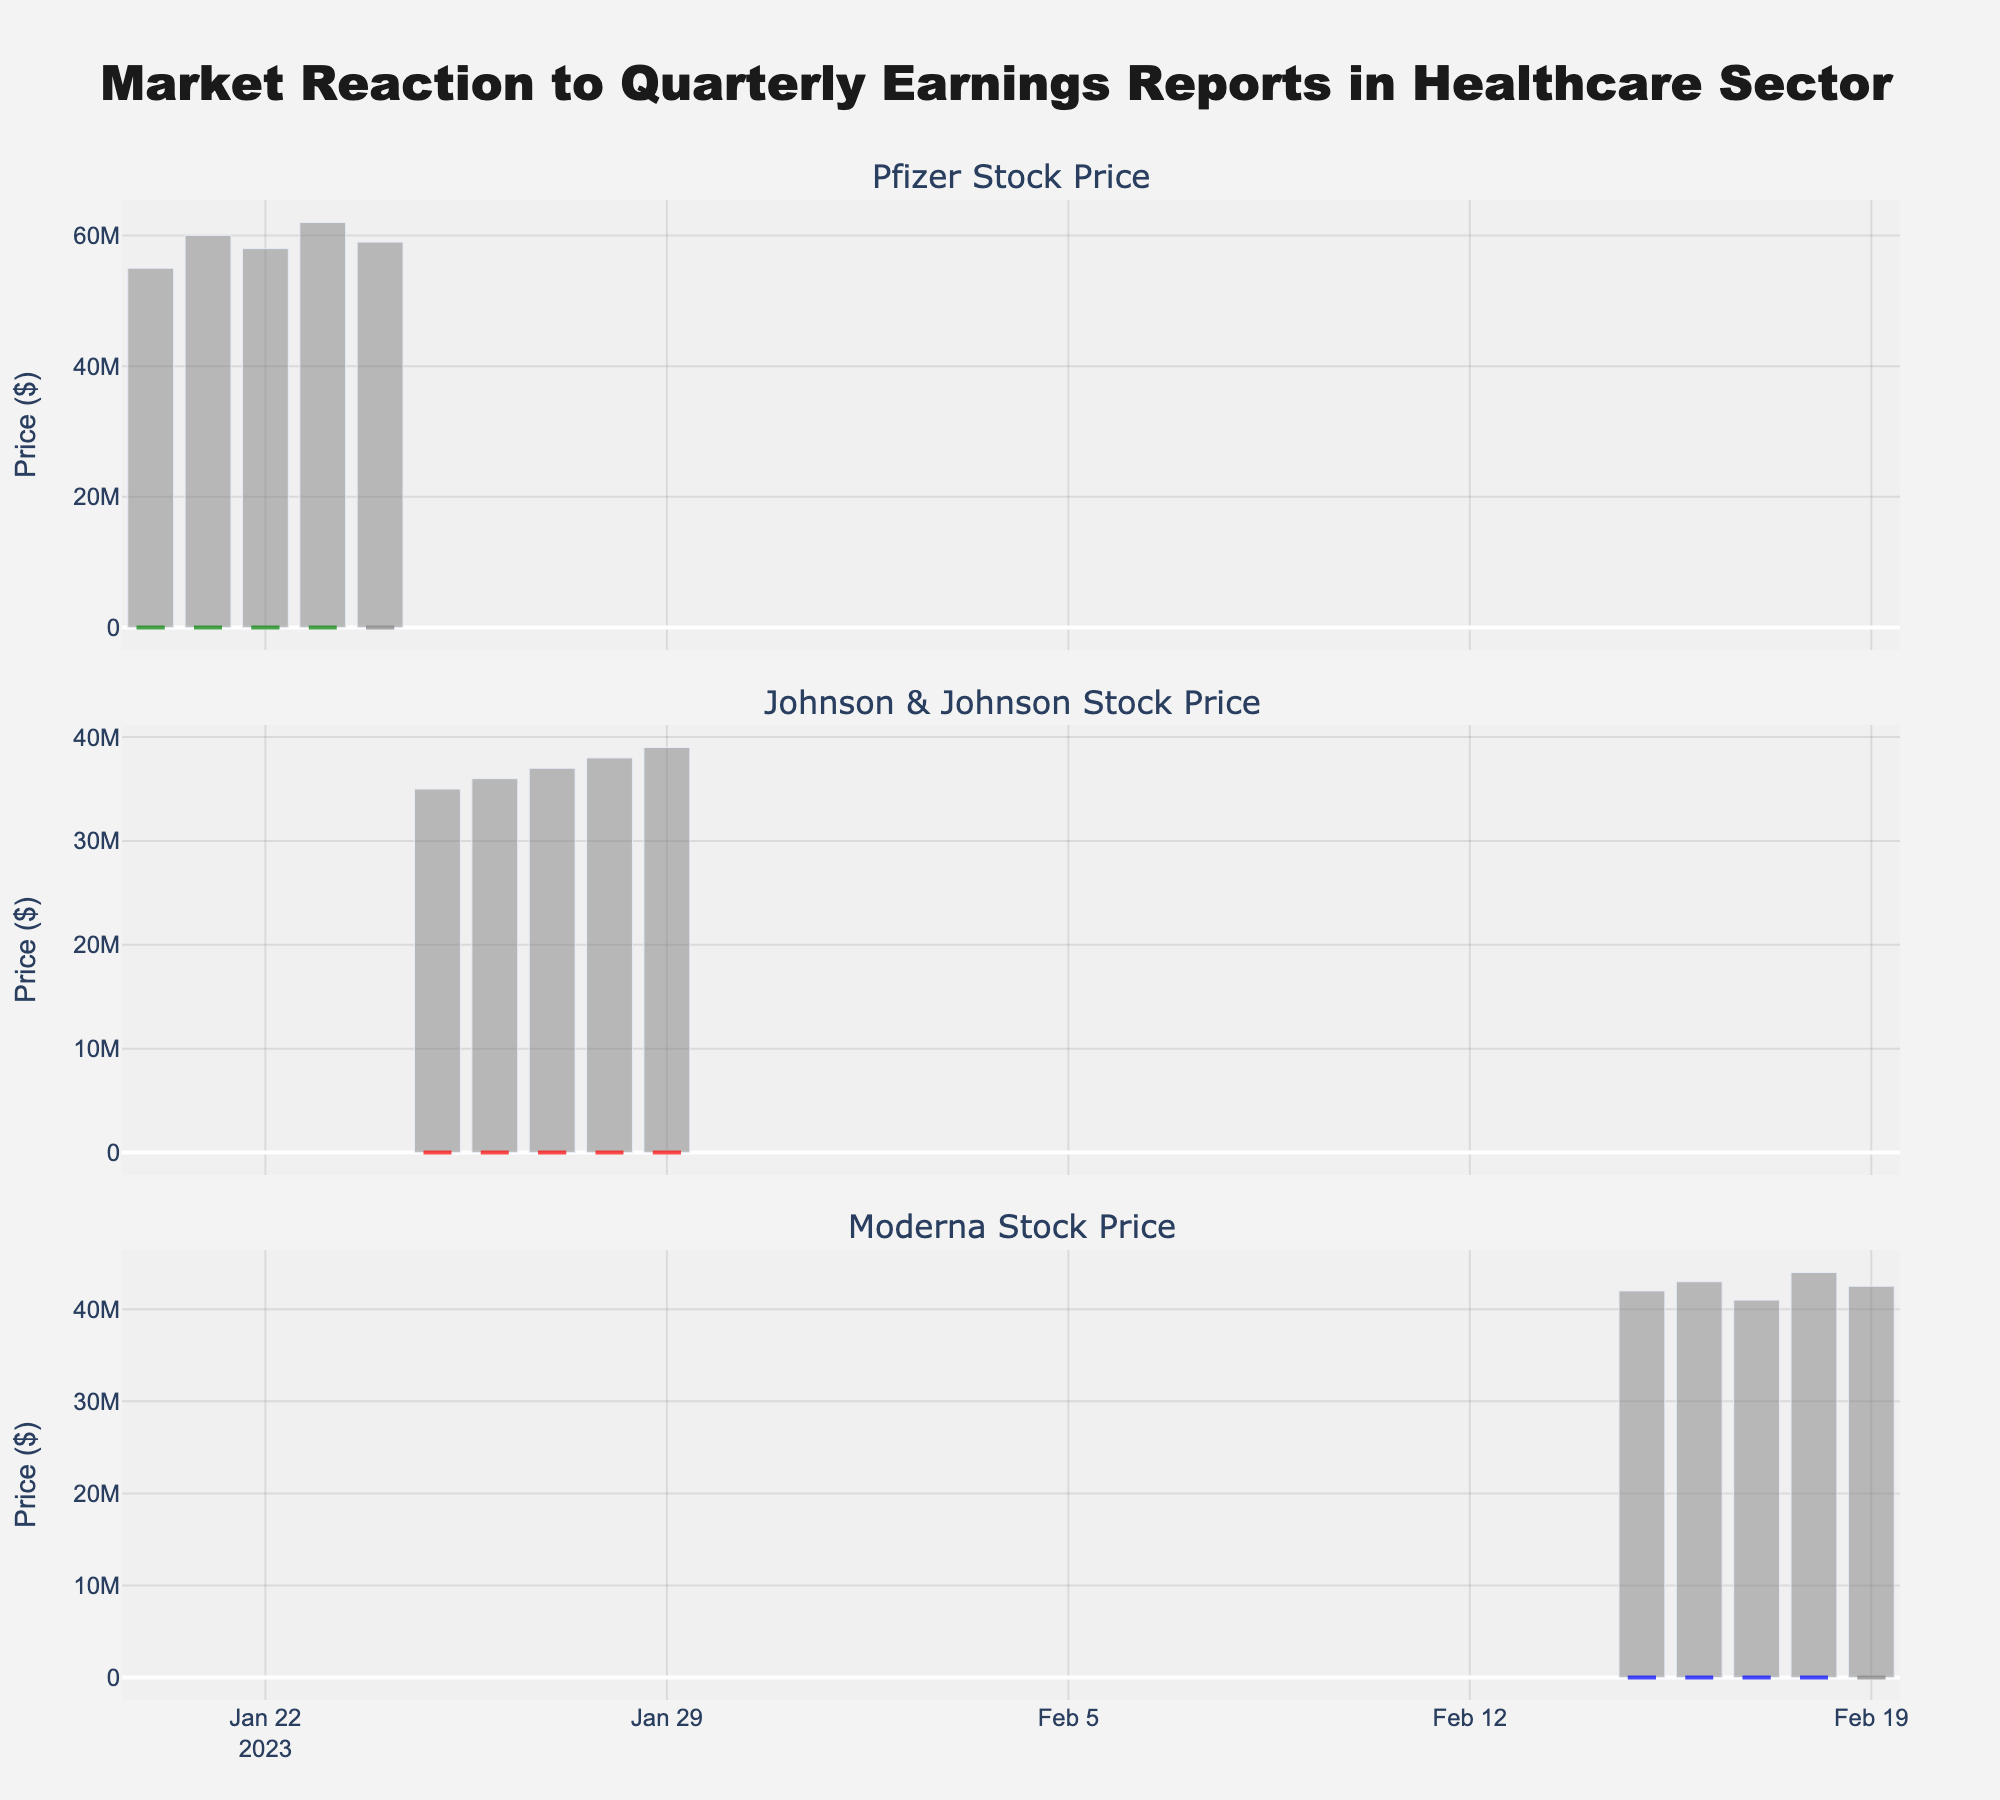What's the title of the plot? The title is located at the top of the plot, summarizing the overall theme.
Answer: "Market Reaction to Quarterly Earnings Reports in Healthcare Sector" What are the names of the companies displayed in the subplot titles? Each subplot corresponds to a different company, with the company name shown in the subplot title.
Answer: Pfizer, Johnson & Johnson, Moderna Which company has the highest recorded closing price within the given dates? To find this, we compare the highest closing prices of Pfizer, Johnson & Johnson, and Moderna by inspecting their respective candlestick closing values.
Answer: Johnson & Johnson For Pfizer, which day had the highest trading volume? Look at the volume bars for Pfizer and identify the tallest bar.
Answer: January 23 Calculate the average closing price for all days listed for Moderna. Add all the closing prices for Moderna and divide by the number of days. Closing prices: 151.7, 152.5, 153.8, 155.1, 154.2. Average = (151.7 + 152.5 + 153.8 + 155.1 + 154.2) / 5
Answer: 153.46 On which day did Johnson & Johnson's stock price have the largest increase from open to close? Look for the largest green (increasing) candlestick for Johnson & Johnson, which indicates the largest positive difference between open and close.
Answer: January 27 Compare the lowest trading price between the companies on the dates provided and identify which company experienced the lowest single trading price. Compare the lowest prices in the candlestick plots for Pfizer, Johnson & Johnson, and Moderna.
Answer: Pfizer What is the trend of Pfizer's stock price over the dates given: increasing, decreasing, or stable? Assess the general direction of the closing prices for Pfizer over the given dates.
Answer: Increasing For Moderna, what was the closing price on February 18? Locate the closing value of the candlestick for Moderna on February 18.
Answer: 155.1 